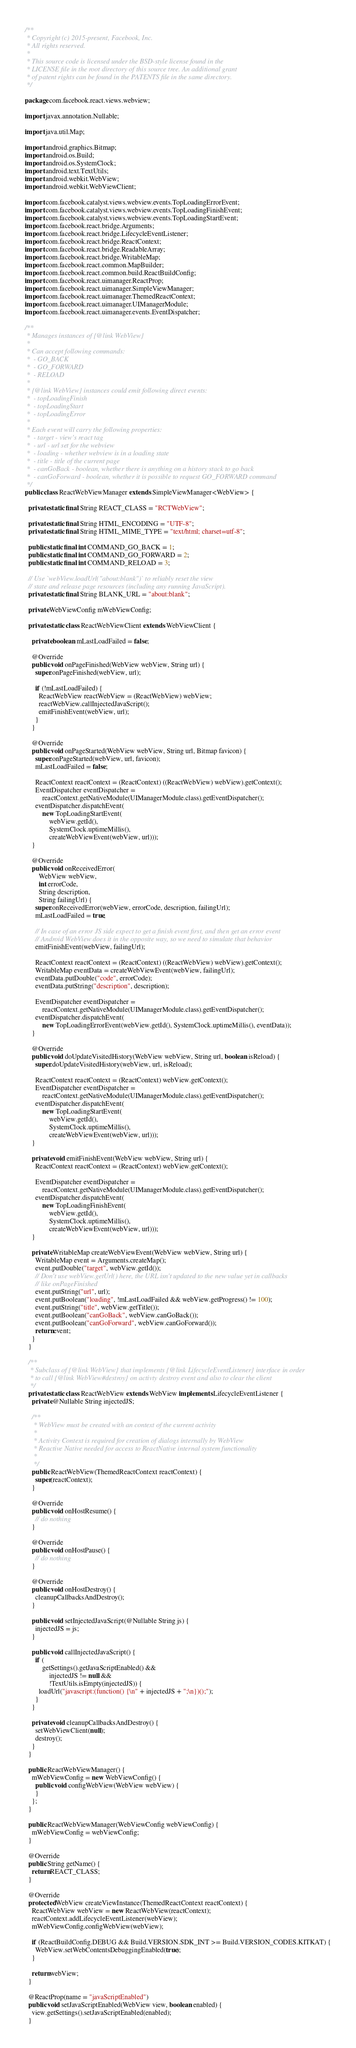<code> <loc_0><loc_0><loc_500><loc_500><_Java_>/**
 * Copyright (c) 2015-present, Facebook, Inc.
 * All rights reserved.
 *
 * This source code is licensed under the BSD-style license found in the
 * LICENSE file in the root directory of this source tree. An additional grant
 * of patent rights can be found in the PATENTS file in the same directory.
 */

package com.facebook.react.views.webview;

import javax.annotation.Nullable;

import java.util.Map;

import android.graphics.Bitmap;
import android.os.Build;
import android.os.SystemClock;
import android.text.TextUtils;
import android.webkit.WebView;
import android.webkit.WebViewClient;

import com.facebook.catalyst.views.webview.events.TopLoadingErrorEvent;
import com.facebook.catalyst.views.webview.events.TopLoadingFinishEvent;
import com.facebook.catalyst.views.webview.events.TopLoadingStartEvent;
import com.facebook.react.bridge.Arguments;
import com.facebook.react.bridge.LifecycleEventListener;
import com.facebook.react.bridge.ReactContext;
import com.facebook.react.bridge.ReadableArray;
import com.facebook.react.bridge.WritableMap;
import com.facebook.react.common.MapBuilder;
import com.facebook.react.common.build.ReactBuildConfig;
import com.facebook.react.uimanager.ReactProp;
import com.facebook.react.uimanager.SimpleViewManager;
import com.facebook.react.uimanager.ThemedReactContext;
import com.facebook.react.uimanager.UIManagerModule;
import com.facebook.react.uimanager.events.EventDispatcher;

/**
 * Manages instances of {@link WebView}
 *
 * Can accept following commands:
 *  - GO_BACK
 *  - GO_FORWARD
 *  - RELOAD
 *
 * {@link WebView} instances could emit following direct events:
 *  - topLoadingFinish
 *  - topLoadingStart
 *  - topLoadingError
 *
 * Each event will carry the following properties:
 *  - target - view's react tag
 *  - url - url set for the webview
 *  - loading - whether webview is in a loading state
 *  - title - title of the current page
 *  - canGoBack - boolean, whether there is anything on a history stack to go back
 *  - canGoForward - boolean, whether it is possible to request GO_FORWARD command
 */
public class ReactWebViewManager extends SimpleViewManager<WebView> {

  private static final String REACT_CLASS = "RCTWebView";

  private static final String HTML_ENCODING = "UTF-8";
  private static final String HTML_MIME_TYPE = "text/html; charset=utf-8";

  public static final int COMMAND_GO_BACK = 1;
  public static final int COMMAND_GO_FORWARD = 2;
  public static final int COMMAND_RELOAD = 3;

  // Use `webView.loadUrl("about:blank")` to reliably reset the view
  // state and release page resources (including any running JavaScript).
  private static final String BLANK_URL = "about:blank";

  private WebViewConfig mWebViewConfig;

  private static class ReactWebViewClient extends WebViewClient {

    private boolean mLastLoadFailed = false;

    @Override
    public void onPageFinished(WebView webView, String url) {
      super.onPageFinished(webView, url);

      if (!mLastLoadFailed) {
        ReactWebView reactWebView = (ReactWebView) webView;
        reactWebView.callInjectedJavaScript();
        emitFinishEvent(webView, url);
      }
    }

    @Override
    public void onPageStarted(WebView webView, String url, Bitmap favicon) {
      super.onPageStarted(webView, url, favicon);
      mLastLoadFailed = false;

      ReactContext reactContext = (ReactContext) ((ReactWebView) webView).getContext();
      EventDispatcher eventDispatcher =
          reactContext.getNativeModule(UIManagerModule.class).getEventDispatcher();
      eventDispatcher.dispatchEvent(
          new TopLoadingStartEvent(
              webView.getId(),
              SystemClock.uptimeMillis(),
              createWebViewEvent(webView, url)));
    }

    @Override
    public void onReceivedError(
        WebView webView,
        int errorCode,
        String description,
        String failingUrl) {
      super.onReceivedError(webView, errorCode, description, failingUrl);
      mLastLoadFailed = true;

      // In case of an error JS side expect to get a finish event first, and then get an error event
      // Android WebView does it in the opposite way, so we need to simulate that behavior
      emitFinishEvent(webView, failingUrl);

      ReactContext reactContext = (ReactContext) ((ReactWebView) webView).getContext();
      WritableMap eventData = createWebViewEvent(webView, failingUrl);
      eventData.putDouble("code", errorCode);
      eventData.putString("description", description);

      EventDispatcher eventDispatcher =
          reactContext.getNativeModule(UIManagerModule.class).getEventDispatcher();
      eventDispatcher.dispatchEvent(
          new TopLoadingErrorEvent(webView.getId(), SystemClock.uptimeMillis(), eventData));
    }

    @Override
    public void doUpdateVisitedHistory(WebView webView, String url, boolean isReload) {
      super.doUpdateVisitedHistory(webView, url, isReload);

      ReactContext reactContext = (ReactContext) webView.getContext();
      EventDispatcher eventDispatcher =
          reactContext.getNativeModule(UIManagerModule.class).getEventDispatcher();
      eventDispatcher.dispatchEvent(
          new TopLoadingStartEvent(
              webView.getId(),
              SystemClock.uptimeMillis(),
              createWebViewEvent(webView, url)));
    }

    private void emitFinishEvent(WebView webView, String url) {
      ReactContext reactContext = (ReactContext) webView.getContext();

      EventDispatcher eventDispatcher =
          reactContext.getNativeModule(UIManagerModule.class).getEventDispatcher();
      eventDispatcher.dispatchEvent(
          new TopLoadingFinishEvent(
              webView.getId(),
              SystemClock.uptimeMillis(),
              createWebViewEvent(webView, url)));
    }

    private WritableMap createWebViewEvent(WebView webView, String url) {
      WritableMap event = Arguments.createMap();
      event.putDouble("target", webView.getId());
      // Don't use webView.getUrl() here, the URL isn't updated to the new value yet in callbacks
      // like onPageFinished
      event.putString("url", url);
      event.putBoolean("loading", !mLastLoadFailed && webView.getProgress() != 100);
      event.putString("title", webView.getTitle());
      event.putBoolean("canGoBack", webView.canGoBack());
      event.putBoolean("canGoForward", webView.canGoForward());
      return event;
    }
  }

  /**
   * Subclass of {@link WebView} that implements {@link LifecycleEventListener} interface in order
   * to call {@link WebView#destroy} on activty destroy event and also to clear the client
   */
  private static class ReactWebView extends WebView implements LifecycleEventListener {
    private @Nullable String injectedJS;

    /**
     * WebView must be created with an context of the current activity
     *
     * Activity Context is required for creation of dialogs internally by WebView
     * Reactive Native needed for access to ReactNative internal system functionality
     *
     */
    public ReactWebView(ThemedReactContext reactContext) {
      super(reactContext);
    }

    @Override
    public void onHostResume() {
      // do nothing
    }

    @Override
    public void onHostPause() {
      // do nothing
    }

    @Override
    public void onHostDestroy() {
      cleanupCallbacksAndDestroy();
    }

    public void setInjectedJavaScript(@Nullable String js) {
      injectedJS = js;
    }

    public void callInjectedJavaScript() {
      if (
          getSettings().getJavaScriptEnabled() &&
              injectedJS != null &&
              !TextUtils.isEmpty(injectedJS)) {
        loadUrl("javascript:(function() {\n" + injectedJS + ";\n})();");
      }
    }

    private void cleanupCallbacksAndDestroy() {
      setWebViewClient(null);
      destroy();
    }
  }

  public ReactWebViewManager() {
    mWebViewConfig = new WebViewConfig() {
      public void configWebView(WebView webView) {
      }
    };
  }

  public ReactWebViewManager(WebViewConfig webViewConfig) {
    mWebViewConfig = webViewConfig;
  }

  @Override
  public String getName() {
    return REACT_CLASS;
  }

  @Override
  protected WebView createViewInstance(ThemedReactContext reactContext) {
    ReactWebView webView = new ReactWebView(reactContext);
    reactContext.addLifecycleEventListener(webView);
    mWebViewConfig.configWebView(webView);

    if (ReactBuildConfig.DEBUG && Build.VERSION.SDK_INT >= Build.VERSION_CODES.KITKAT) {
      WebView.setWebContentsDebuggingEnabled(true);
    }

    return webView;
  }

  @ReactProp(name = "javaScriptEnabled")
  public void setJavaScriptEnabled(WebView view, boolean enabled) {
    view.getSettings().setJavaScriptEnabled(enabled);
  }
</code> 